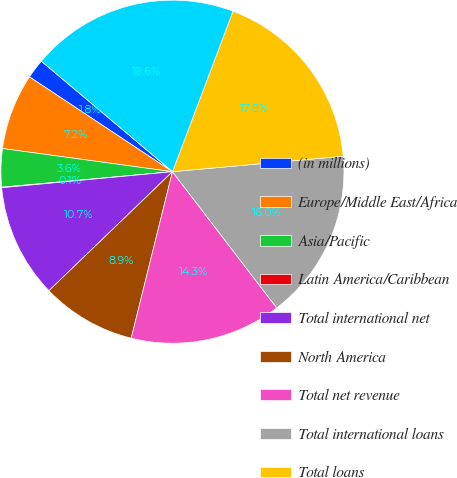Convert chart. <chart><loc_0><loc_0><loc_500><loc_500><pie_chart><fcel>(in millions)<fcel>Europe/Middle East/Africa<fcel>Asia/Pacific<fcel>Latin America/Caribbean<fcel>Total international net<fcel>North America<fcel>Total net revenue<fcel>Total international loans<fcel>Total loans<fcel>Total international<nl><fcel>1.83%<fcel>7.16%<fcel>3.6%<fcel>0.05%<fcel>10.71%<fcel>8.93%<fcel>14.26%<fcel>16.04%<fcel>17.82%<fcel>19.59%<nl></chart> 